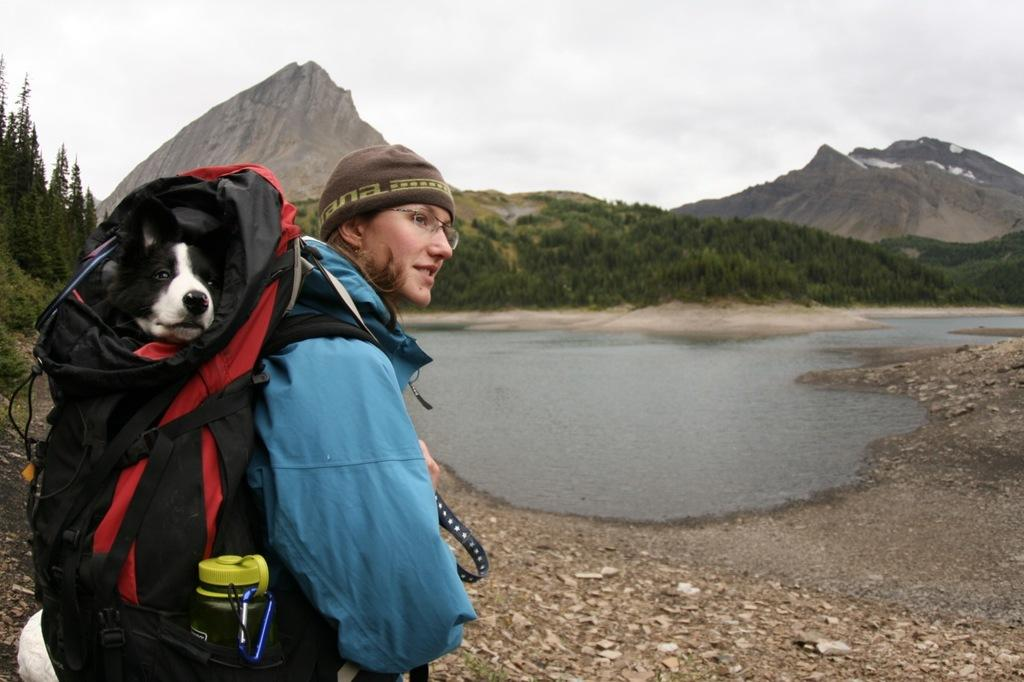Who or what is the main subject in the image? There is a person in the image. What is the person wearing on their back? The person is wearing a backpack. What can be found inside the backpack? There is a dog and a bottle inside the backpack. What is visible in front of the person? There is water visible in front of the person. What can be seen in the background of the image? There are trees and mountains in the background of the image. What type of lunch is the person eating in the image? There is no lunch visible in the image; the person is wearing a backpack with a dog and a bottle inside. Can you hear the drum being played in the image? There is no drum present in the image, so it cannot be heard. 